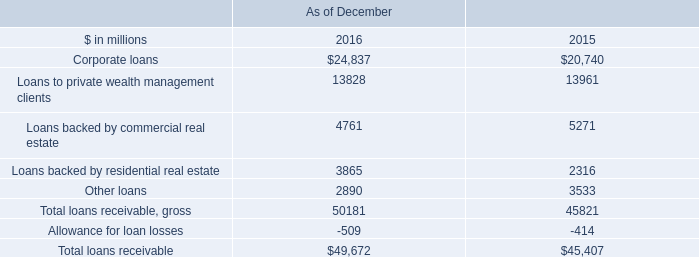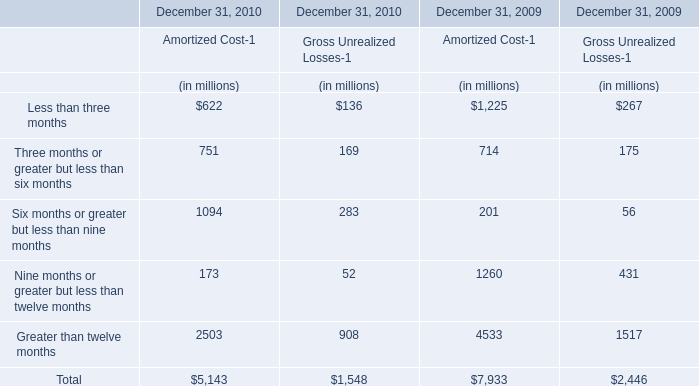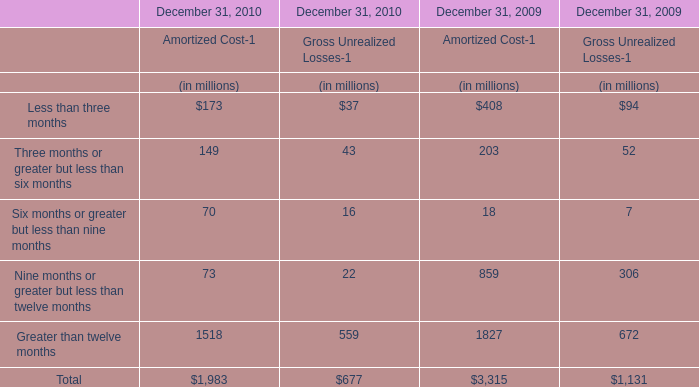What's the current growth rate of Less than three months for Gross Unrealized Losses-1? 
Computations: ((37 - 94) / 94)
Answer: -0.60638. 